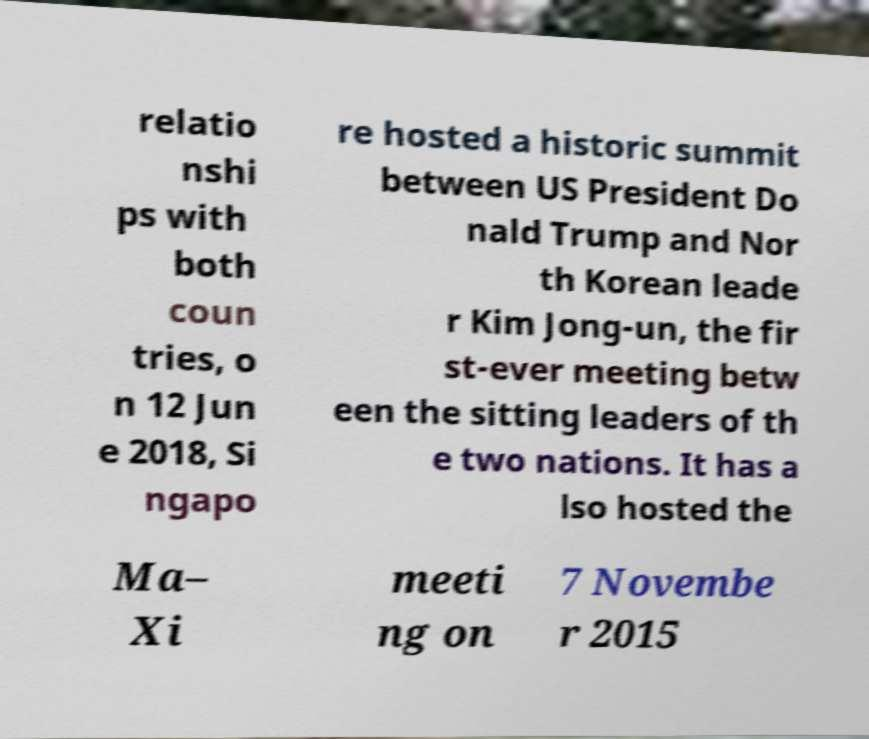Please read and relay the text visible in this image. What does it say? relatio nshi ps with both coun tries, o n 12 Jun e 2018, Si ngapo re hosted a historic summit between US President Do nald Trump and Nor th Korean leade r Kim Jong-un, the fir st-ever meeting betw een the sitting leaders of th e two nations. It has a lso hosted the Ma– Xi meeti ng on 7 Novembe r 2015 